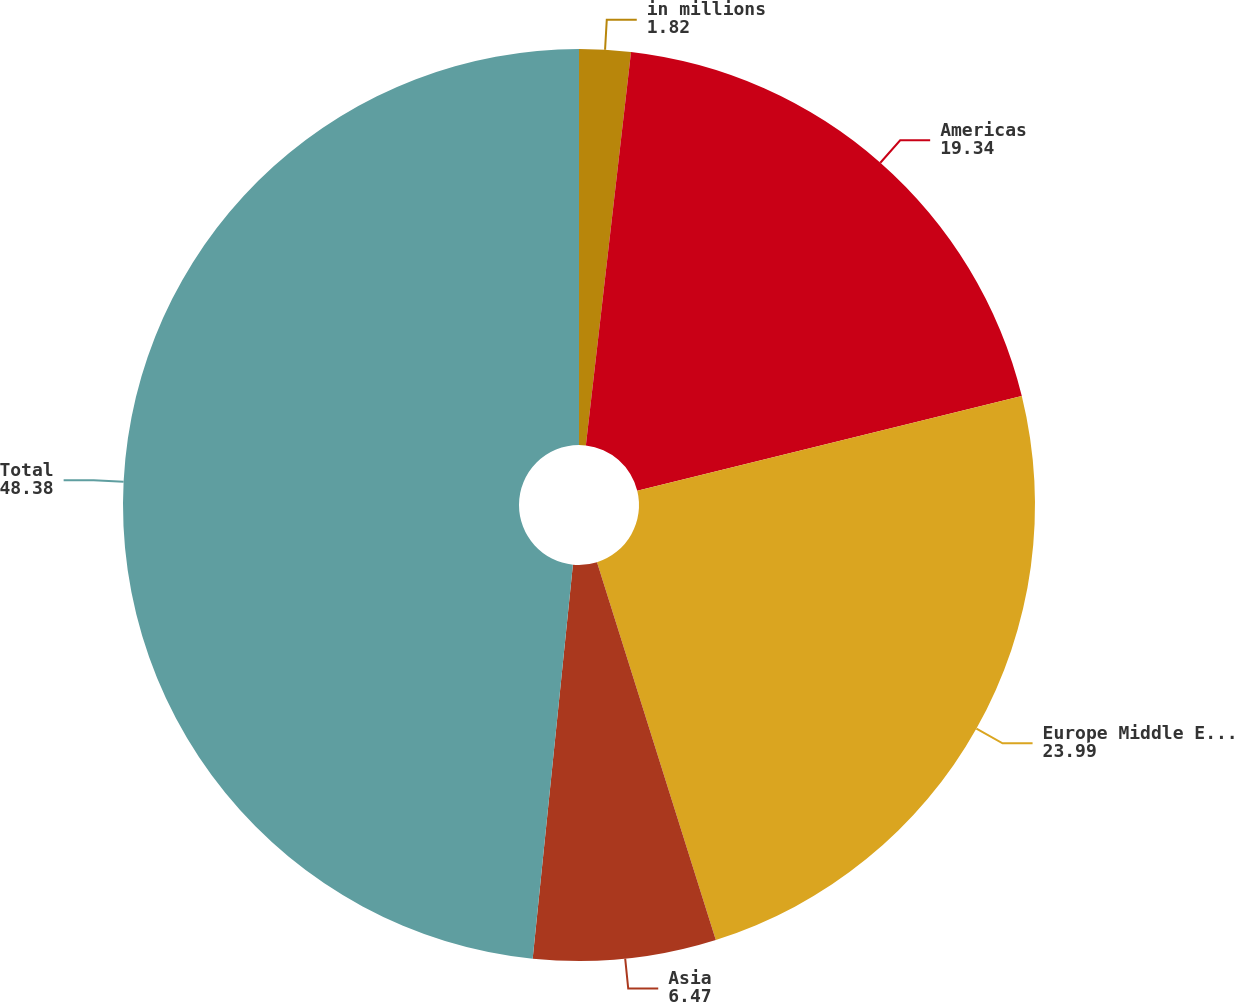Convert chart. <chart><loc_0><loc_0><loc_500><loc_500><pie_chart><fcel>in millions<fcel>Americas<fcel>Europe Middle East and Africa<fcel>Asia<fcel>Total<nl><fcel>1.82%<fcel>19.34%<fcel>23.99%<fcel>6.47%<fcel>48.38%<nl></chart> 